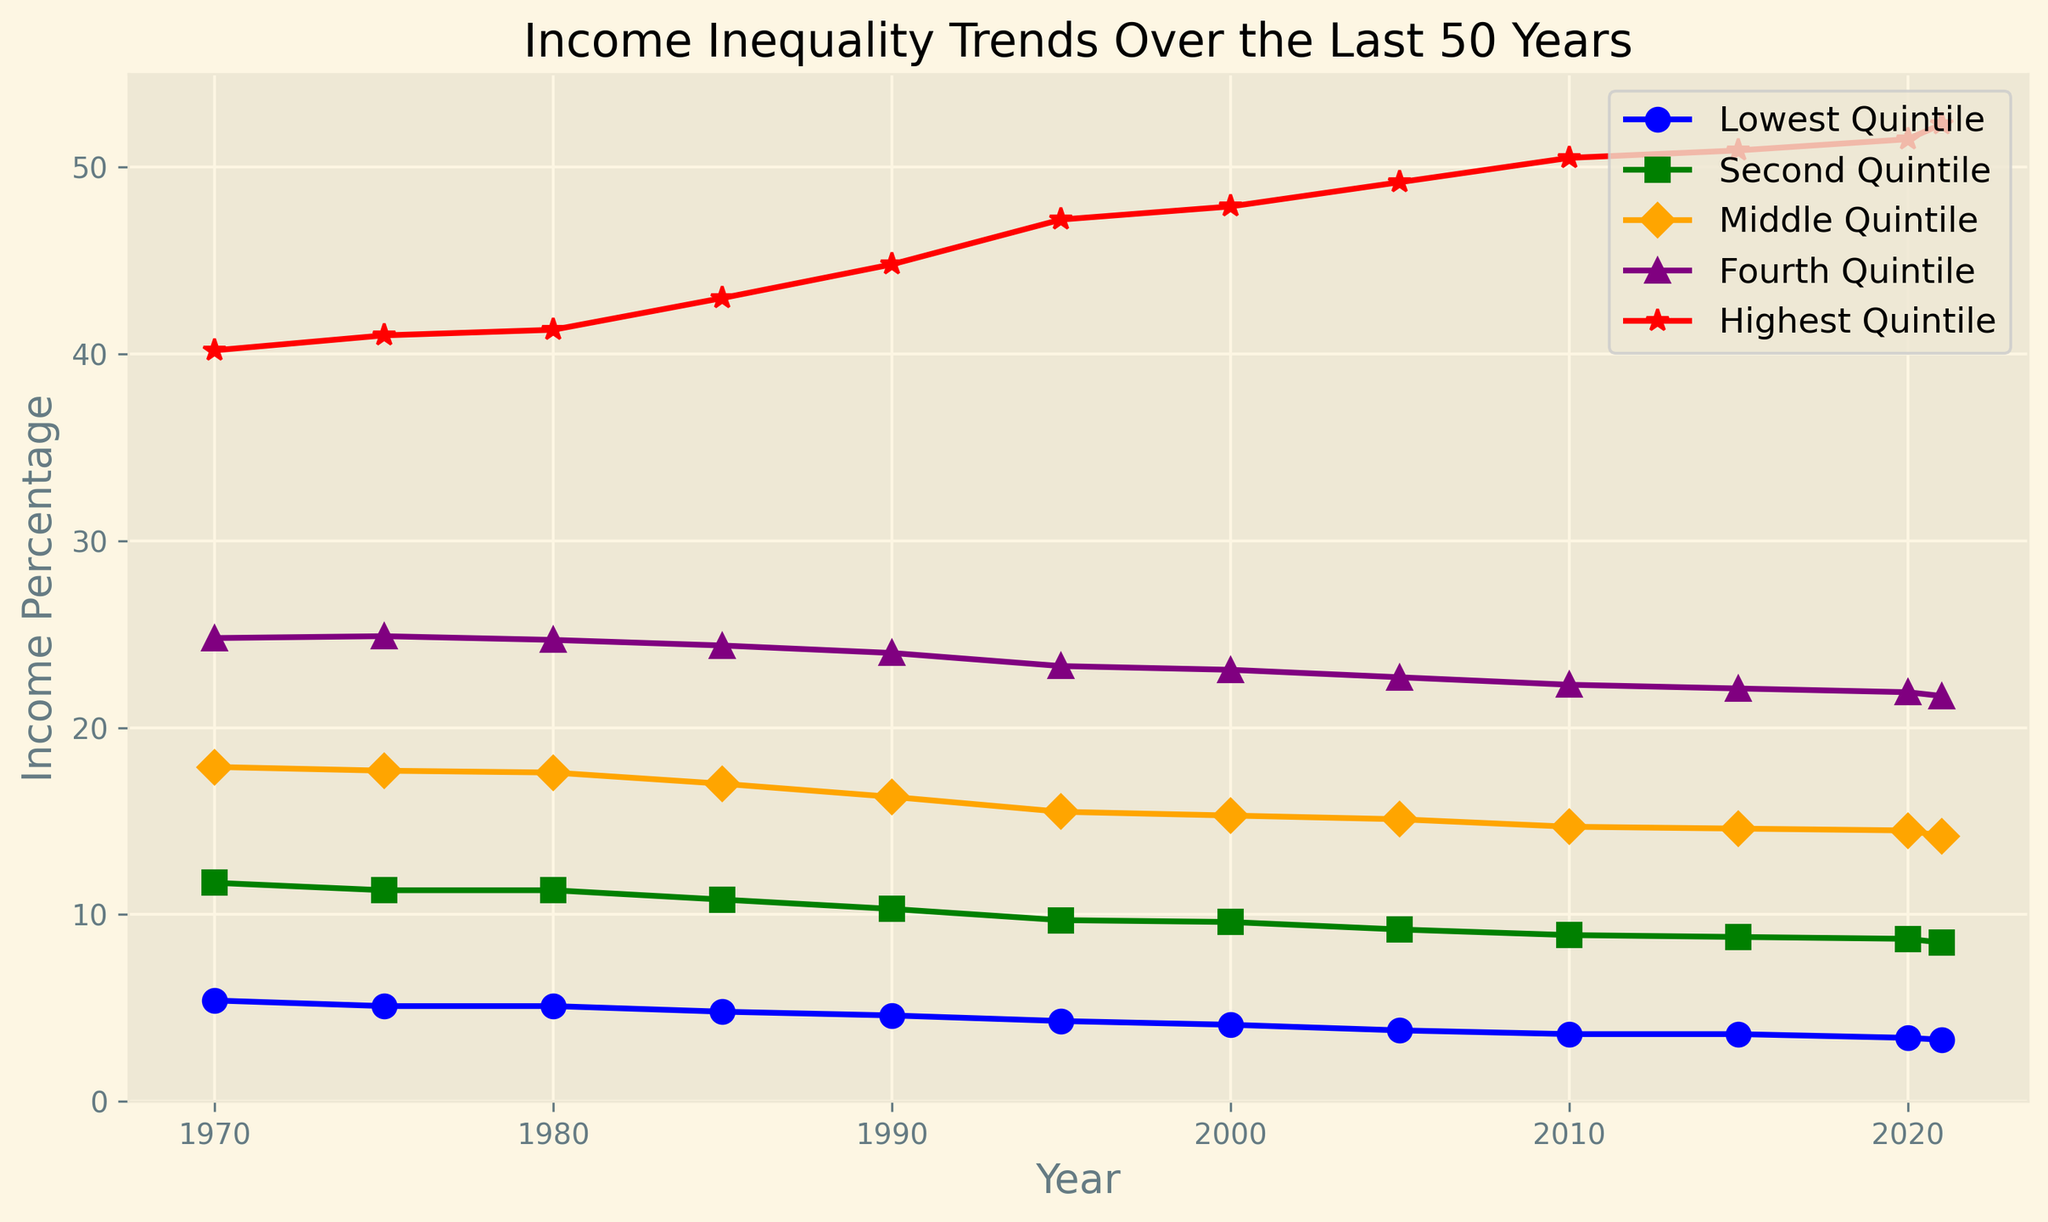What trend can you observe in the highest quintile from 1970 to 2021? The highest quintile shows a consistent upward trend from 40.2% in 1970 to 52.3% in 2021. This indicates increasing income share for the top 20% over the last 50 years.
Answer: Increasing trend How does the income percentage of the lowest quintile in 2021 compare to that in 1970? In 1970, the lowest quintile's income percentage was 5.4%, and in 2021, it was 3.3%. Comparing these, the income share decreased by 2.1 percentage points (5.4% - 3.3%).
Answer: Decreased by 2.1 percentage points Which quintile had the least change in income percentage over the years? Examining the trends, the Fourth Quintile experienced relatively minimal fluctuations, starting at 24.8% in 1970 and ending at 21.7% in 2021, a change of 3.1 percentage points. This is smaller compared to the other quintiles.
Answer: Fourth Quintile Compare the income percentage of the middle quintile and the second quintile in 2021. In 2021, the middle quintile had an income percentage of 14.2%, and the second quintile had 8.5%. Subtracting these values (14.2% - 8.5%), the middle quintile had a 5.7 percentage points higher share.
Answer: Middle Quintile is 5.7 percentage points higher What is the average income percentage across all quintiles in 2000? For 2000, the income percentages are 4.1, 9.6, 15.3, 23.1, and 47.9. Sum these values (4.1 + 9.6 + 15.3 + 23.1 + 47.9 = 100) and divide by 5 (100/5). The average income percentage is 20%.
Answer: 20% Which quintile depicts the steepest decline in income percentage from 1970 to 2021? The lowest quintile declines from 5.4% in 1970 to 3.3% in 2021, totaling a decrease of 2.1 percentage points. The percentage change is higher compared to the other quintiles.
Answer: Lowest Quintile During which decade did the highest quintile experience the largest increase in income percentage? From 1990 to 2000, the highest quintile increased from 44.8% to 47.9%, a change of 3.1 percentage points. This decade shows the largest increase compared to others.
Answer: 1990s How many quintiles have consistently decreased their income percentage from 1970 to 2021? Both the lowest and the second quintiles consistently decreased their income percentages over this period.
Answer: Two quintiles What visual attribute is used to differentiate the quintiles in the chart? Different line styles and marker shapes such as -o, -s, -D, -^, and -*, along with distinct colors like blue, green, orange, purple, and red, are used to visually differentiate between quintiles.
Answer: Line styles and colors Compare the highest income percentage (highest quintile) to the lowest income percentage (lowest quintile) in 1985. In 1985, the highest quintile had 43.0%, while the lowest quintile had 4.8%. The difference (43.0% - 4.8%) is 38.2 percentage points.
Answer: 38.2 percentage points 